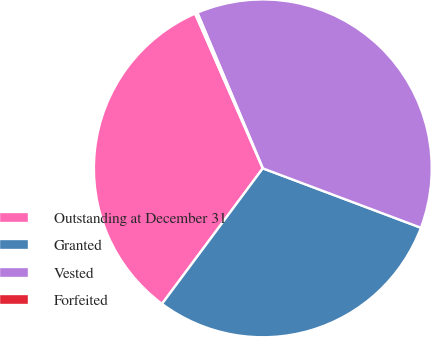Convert chart to OTSL. <chart><loc_0><loc_0><loc_500><loc_500><pie_chart><fcel>Outstanding at December 31<fcel>Granted<fcel>Vested<fcel>Forfeited<nl><fcel>33.26%<fcel>29.46%<fcel>37.06%<fcel>0.23%<nl></chart> 